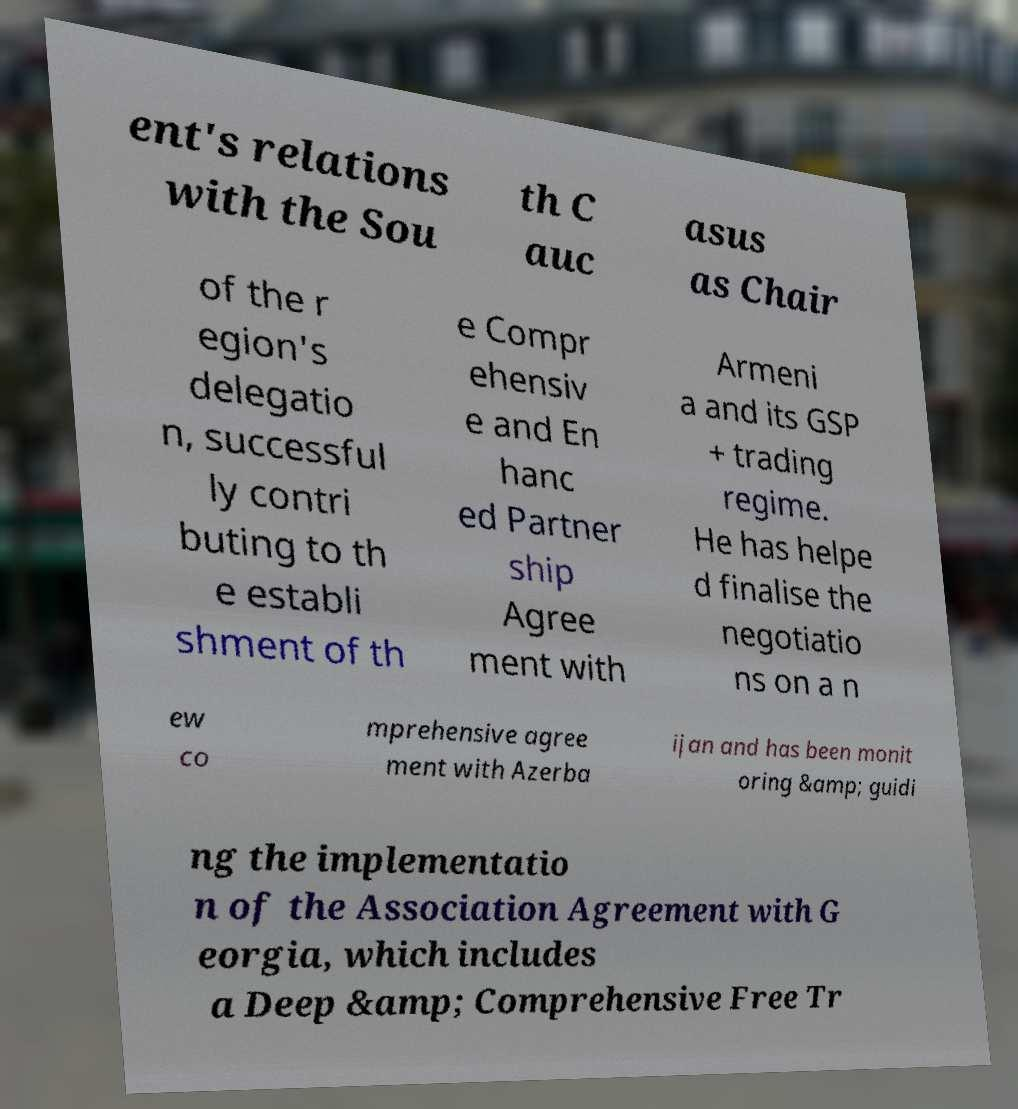Can you accurately transcribe the text from the provided image for me? ent's relations with the Sou th C auc asus as Chair of the r egion's delegatio n, successful ly contri buting to th e establi shment of th e Compr ehensiv e and En hanc ed Partner ship Agree ment with Armeni a and its GSP + trading regime. He has helpe d finalise the negotiatio ns on a n ew co mprehensive agree ment with Azerba ijan and has been monit oring &amp; guidi ng the implementatio n of the Association Agreement with G eorgia, which includes a Deep &amp; Comprehensive Free Tr 